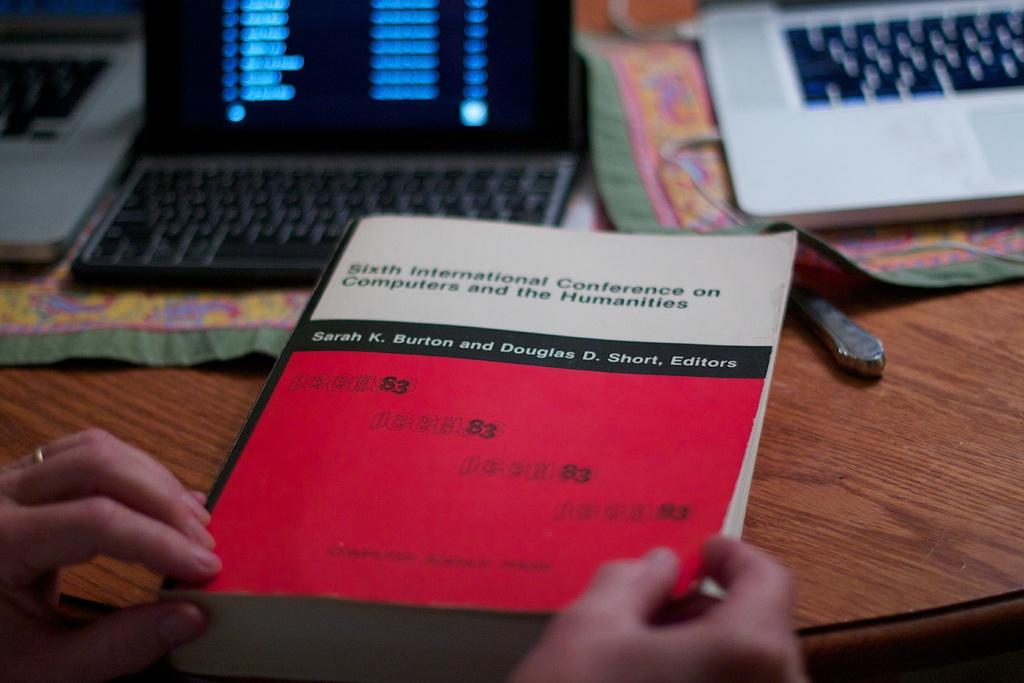<image>
Present a compact description of the photo's key features. Person holding a white and red book titled "Sixth International Conference on Computers and the HUmanities". 